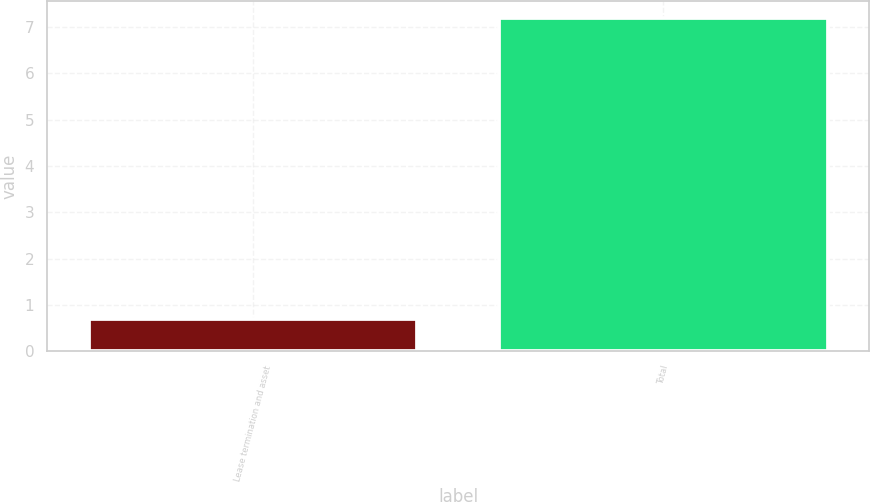Convert chart to OTSL. <chart><loc_0><loc_0><loc_500><loc_500><bar_chart><fcel>Lease termination and asset<fcel>Total<nl><fcel>0.7<fcel>7.2<nl></chart> 